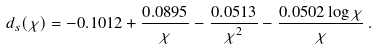<formula> <loc_0><loc_0><loc_500><loc_500>d _ { s } ( \chi ) = - 0 . 1 0 1 2 + \frac { 0 . 0 8 9 5 } { \chi } - \frac { 0 . 0 5 1 3 } { \chi ^ { 2 } } - \frac { 0 . 0 5 0 2 \log \chi } { \chi } \, .</formula> 